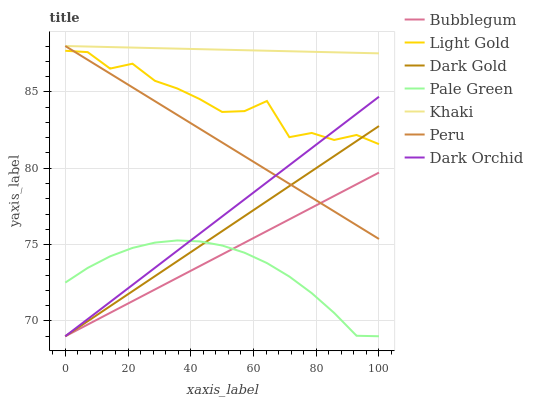Does Dark Gold have the minimum area under the curve?
Answer yes or no. No. Does Dark Gold have the maximum area under the curve?
Answer yes or no. No. Is Dark Gold the smoothest?
Answer yes or no. No. Is Dark Gold the roughest?
Answer yes or no. No. Does Peru have the lowest value?
Answer yes or no. No. Does Dark Gold have the highest value?
Answer yes or no. No. Is Dark Gold less than Khaki?
Answer yes or no. Yes. Is Khaki greater than Light Gold?
Answer yes or no. Yes. Does Dark Gold intersect Khaki?
Answer yes or no. No. 